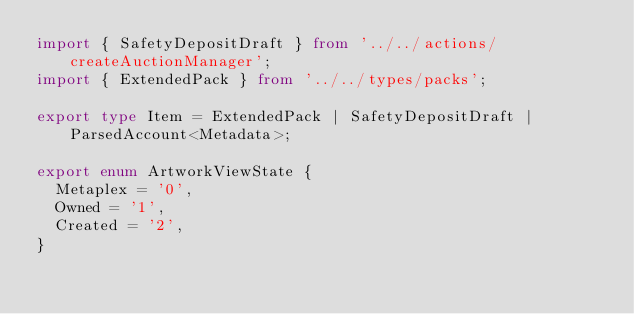<code> <loc_0><loc_0><loc_500><loc_500><_TypeScript_>import { SafetyDepositDraft } from '../../actions/createAuctionManager';
import { ExtendedPack } from '../../types/packs';

export type Item = ExtendedPack | SafetyDepositDraft | ParsedAccount<Metadata>;

export enum ArtworkViewState {
  Metaplex = '0',
  Owned = '1',
  Created = '2',
}
</code> 